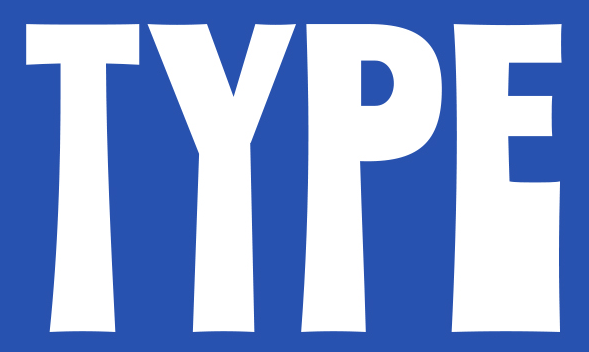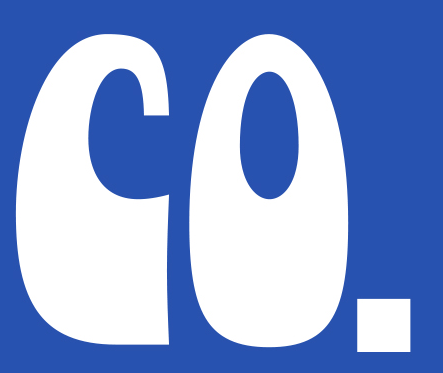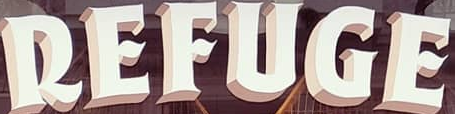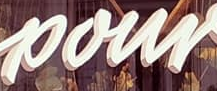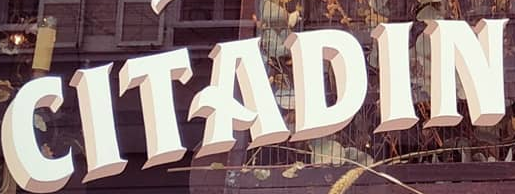What text is displayed in these images sequentially, separated by a semicolon? TYPE; CO.; REFUGE; pour; CITADIN 